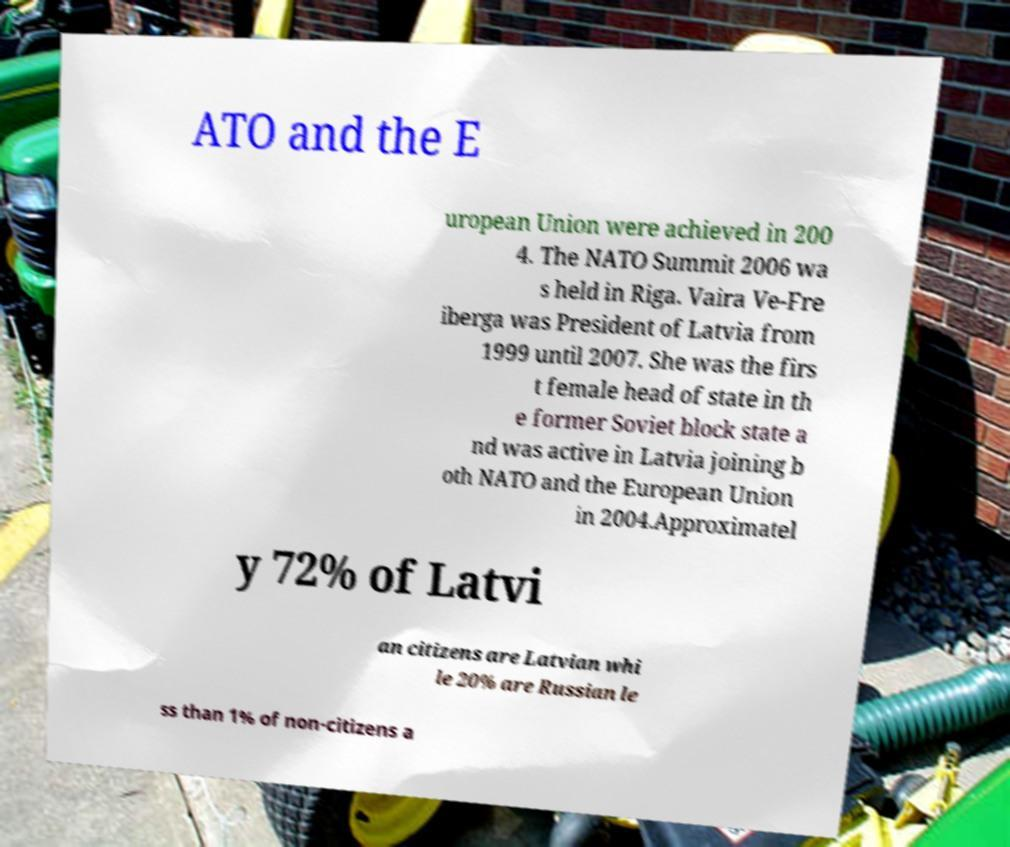Please read and relay the text visible in this image. What does it say? ATO and the E uropean Union were achieved in 200 4. The NATO Summit 2006 wa s held in Riga. Vaira Ve-Fre iberga was President of Latvia from 1999 until 2007. She was the firs t female head of state in th e former Soviet block state a nd was active in Latvia joining b oth NATO and the European Union in 2004.Approximatel y 72% of Latvi an citizens are Latvian whi le 20% are Russian le ss than 1% of non-citizens a 